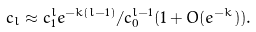<formula> <loc_0><loc_0><loc_500><loc_500>c _ { l } \approx c _ { 1 } ^ { l } e ^ { - k ( l - 1 ) } / c _ { 0 } ^ { l - 1 } ( 1 + O ( e ^ { - k } ) ) .</formula> 